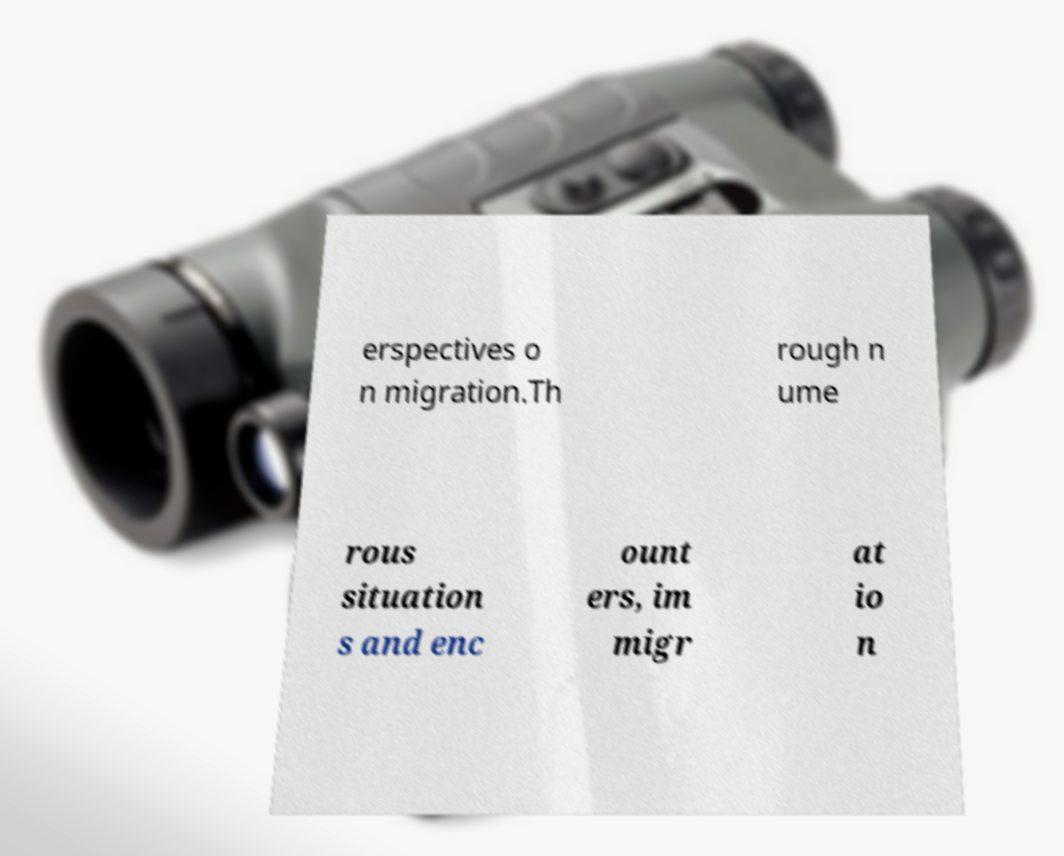Please read and relay the text visible in this image. What does it say? erspectives o n migration.Th rough n ume rous situation s and enc ount ers, im migr at io n 